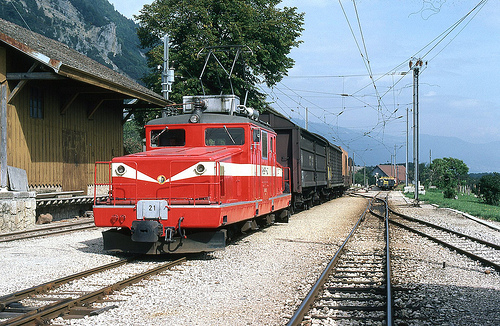What is the function of the vehicle shown at the center of the image? The vehicle at the center is a locomotive, primarily used for hauling freight cars along the railway. 